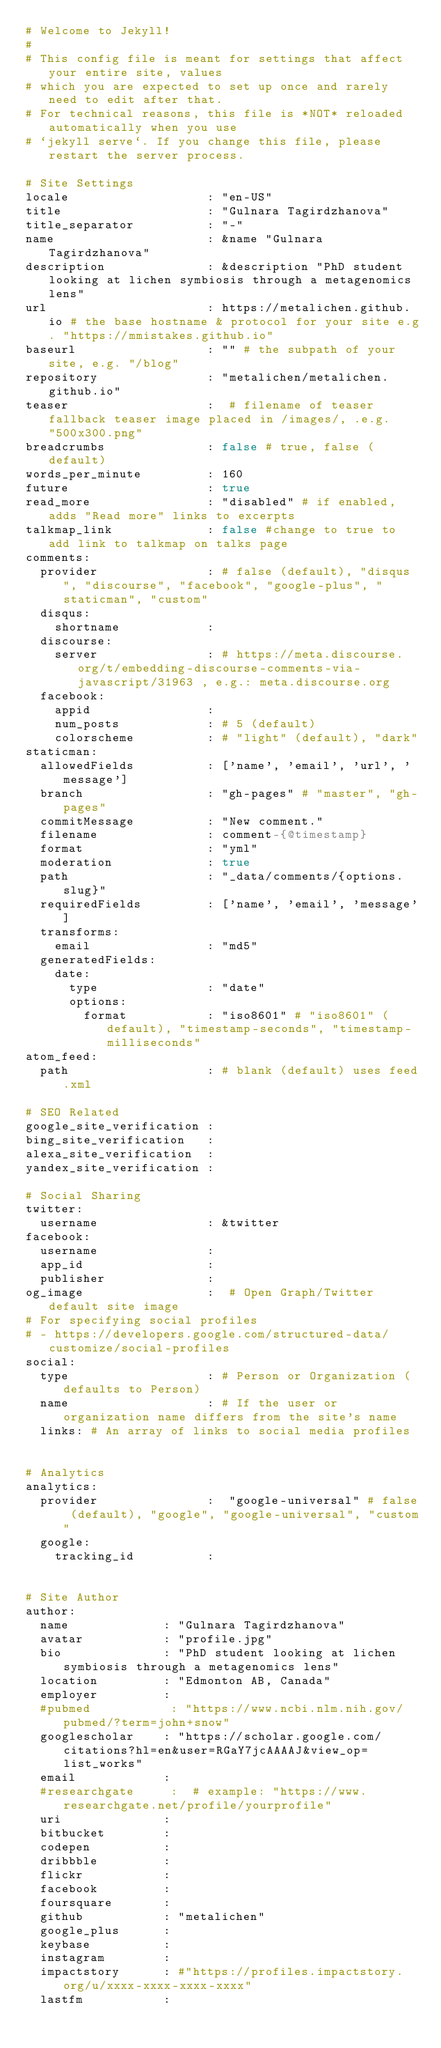Convert code to text. <code><loc_0><loc_0><loc_500><loc_500><_YAML_># Welcome to Jekyll!
#
# This config file is meant for settings that affect your entire site, values
# which you are expected to set up once and rarely need to edit after that.
# For technical reasons, this file is *NOT* reloaded automatically when you use
# `jekyll serve`. If you change this file, please restart the server process.

# Site Settings
locale                   : "en-US"
title                    : "Gulnara Tagirdzhanova"
title_separator          : "-"
name                     : &name "Gulnara Tagirdzhanova"
description              : &description "PhD student looking at lichen symbiosis through a metagenomics lens"
url                      : https://metalichen.github.io # the base hostname & protocol for your site e.g. "https://mmistakes.github.io"
baseurl                  : "" # the subpath of your site, e.g. "/blog"
repository               : "metalichen/metalichen.github.io"
teaser                   :  # filename of teaser fallback teaser image placed in /images/, .e.g. "500x300.png"
breadcrumbs              : false # true, false (default)
words_per_minute         : 160
future                   : true
read_more                : "disabled" # if enabled, adds "Read more" links to excerpts
talkmap_link             : false #change to true to add link to talkmap on talks page
comments:
  provider               : # false (default), "disqus", "discourse", "facebook", "google-plus", "staticman", "custom"
  disqus:
    shortname            :
  discourse:
    server               : # https://meta.discourse.org/t/embedding-discourse-comments-via-javascript/31963 , e.g.: meta.discourse.org
  facebook:
    appid                :
    num_posts            : # 5 (default)
    colorscheme          : # "light" (default), "dark"
staticman:
  allowedFields          : ['name', 'email', 'url', 'message']
  branch                 : "gh-pages" # "master", "gh-pages"
  commitMessage          : "New comment."
  filename               : comment-{@timestamp}
  format                 : "yml"
  moderation             : true
  path                   : "_data/comments/{options.slug}"
  requiredFields         : ['name', 'email', 'message']
  transforms:
    email                : "md5"
  generatedFields:
    date:
      type               : "date"
      options:
        format           : "iso8601" # "iso8601" (default), "timestamp-seconds", "timestamp-milliseconds"
atom_feed:
  path                   : # blank (default) uses feed.xml

# SEO Related
google_site_verification :
bing_site_verification   :
alexa_site_verification  :
yandex_site_verification :

# Social Sharing
twitter:
  username               : &twitter
facebook:
  username               :
  app_id                 :
  publisher              :
og_image                 :  # Open Graph/Twitter default site image
# For specifying social profiles
# - https://developers.google.com/structured-data/customize/social-profiles
social:
  type                   : # Person or Organization (defaults to Person)
  name                   : # If the user or organization name differs from the site's name
  links: # An array of links to social media profiles


# Analytics
analytics:
  provider               :  "google-universal" # false (default), "google", "google-universal", "custom"
  google:
    tracking_id          :


# Site Author
author:
  name             : "Gulnara Tagirdzhanova"
  avatar           : "profile.jpg"
  bio              : "PhD student looking at lichen symbiosis through a metagenomics lens"
  location         : "Edmonton AB, Canada"
  employer         :
  #pubmed           : "https://www.ncbi.nlm.nih.gov/pubmed/?term=john+snow"
  googlescholar    : "https://scholar.google.com/citations?hl=en&user=RGaY7jcAAAAJ&view_op=list_works"
  email            :  
  #researchgate     :  # example: "https://www.researchgate.net/profile/yourprofile"
  uri              :
  bitbucket        :
  codepen          :
  dribbble         :
  flickr           :
  facebook         :
  foursquare       :
  github           : "metalichen"
  google_plus      :
  keybase          :
  instagram        :
  impactstory      : #"https://profiles.impactstory.org/u/xxxx-xxxx-xxxx-xxxx"
  lastfm           :</code> 